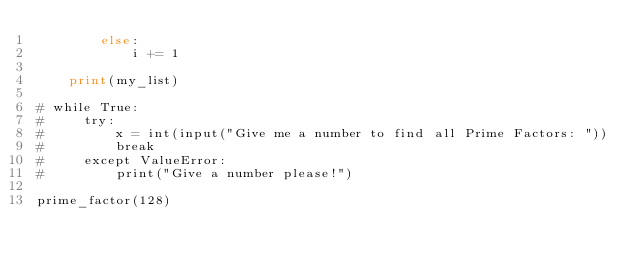Convert code to text. <code><loc_0><loc_0><loc_500><loc_500><_Python_>        else:
            i += 1

    print(my_list)

# while True:
#     try:
#         x = int(input("Give me a number to find all Prime Factors: "))
#         break
#     except ValueError:
#         print("Give a number please!")

prime_factor(128)</code> 